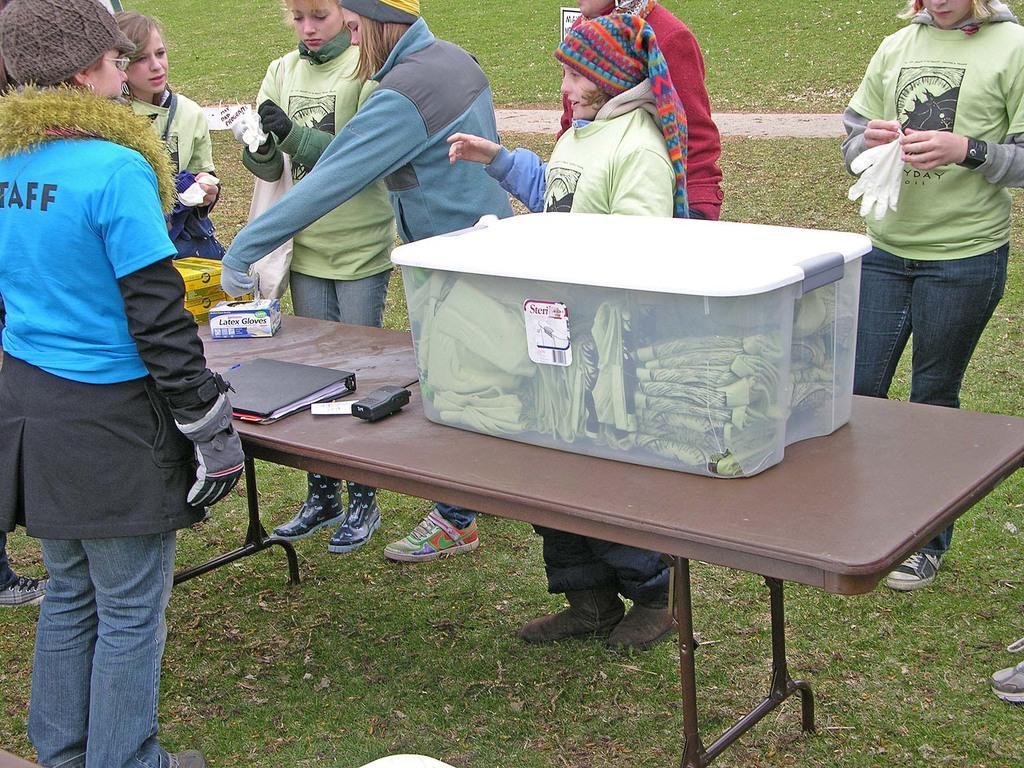How would you summarize this image in a sentence or two? In the image we can see there are people who are standing on the grass and on the table there is a box in which there are t shirts. 